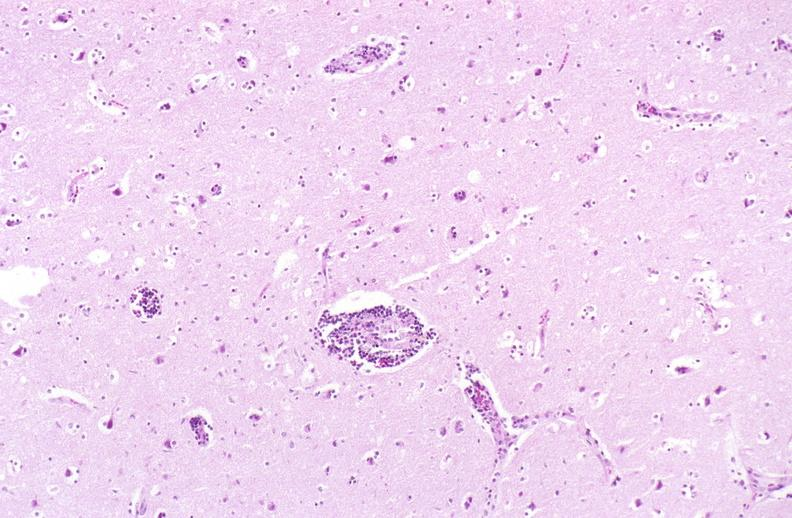s embryo-fetus present?
Answer the question using a single word or phrase. No 